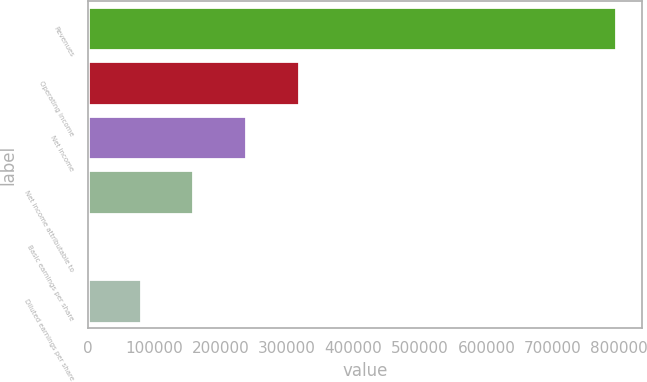Convert chart. <chart><loc_0><loc_0><loc_500><loc_500><bar_chart><fcel>Revenues<fcel>Operating income<fcel>Net income<fcel>Net income attributable to<fcel>Basic earnings per share<fcel>Diluted earnings per share<nl><fcel>794977<fcel>317991<fcel>238493<fcel>158996<fcel>0.57<fcel>79498.2<nl></chart> 